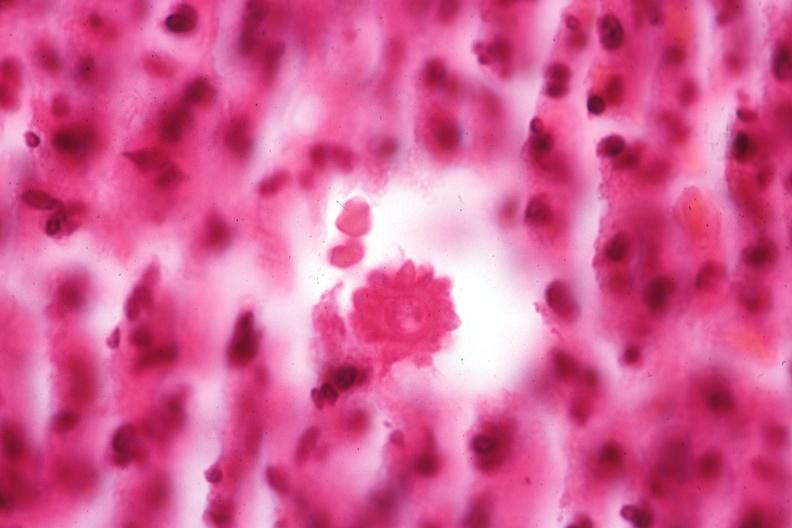does this image show oil immersion organism very well shown?
Answer the question using a single word or phrase. Yes 